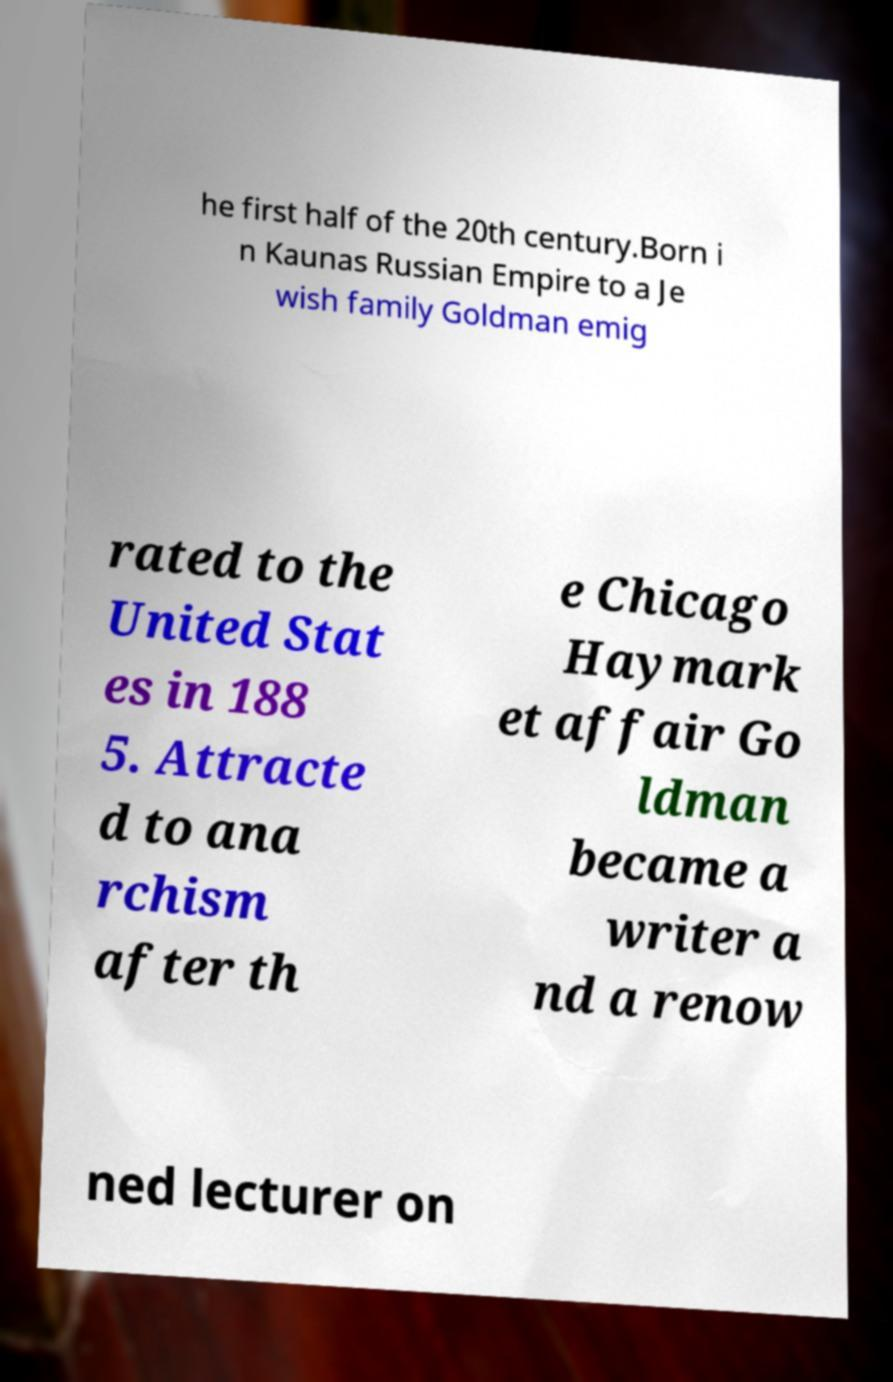There's text embedded in this image that I need extracted. Can you transcribe it verbatim? he first half of the 20th century.Born i n Kaunas Russian Empire to a Je wish family Goldman emig rated to the United Stat es in 188 5. Attracte d to ana rchism after th e Chicago Haymark et affair Go ldman became a writer a nd a renow ned lecturer on 